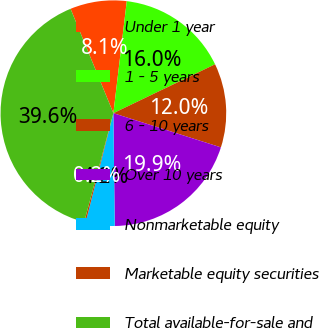<chart> <loc_0><loc_0><loc_500><loc_500><pie_chart><fcel>Under 1 year<fcel>1 - 5 years<fcel>6 - 10 years<fcel>Over 10 years<fcel>Nonmarketable equity<fcel>Marketable equity securities<fcel>Total available-for-sale and<nl><fcel>8.09%<fcel>15.97%<fcel>12.03%<fcel>19.91%<fcel>4.15%<fcel>0.21%<fcel>39.62%<nl></chart> 